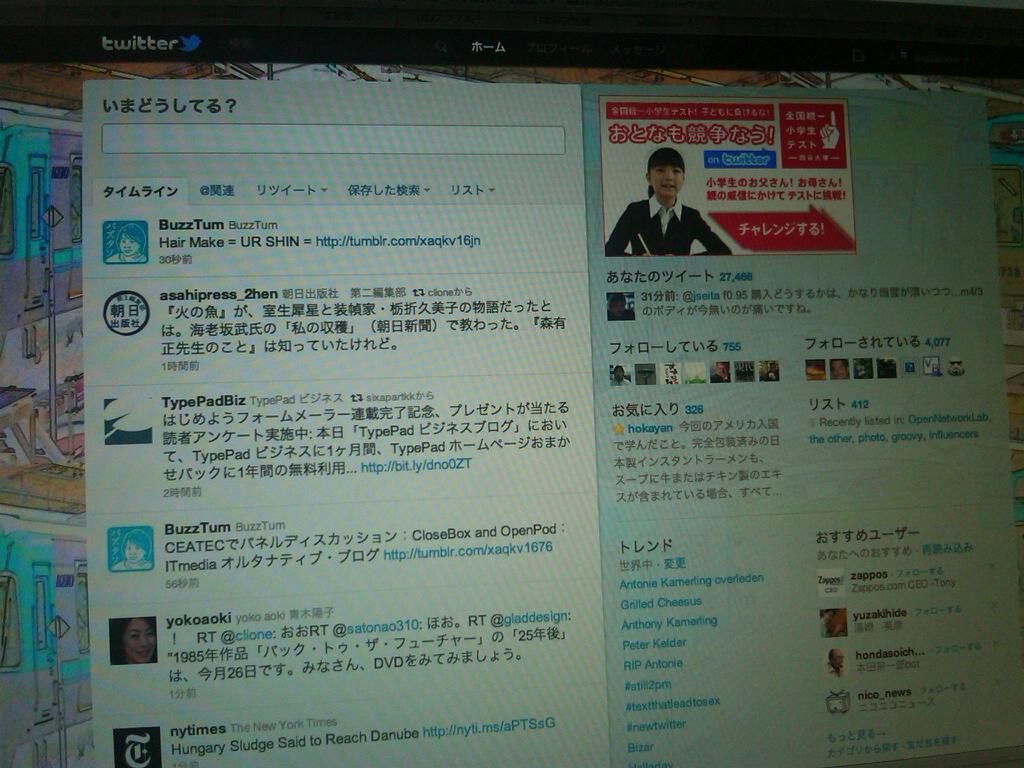<image>
Present a compact description of the photo's key features. A monitor screen that has twitter on it and a profile up. 